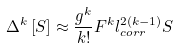Convert formula to latex. <formula><loc_0><loc_0><loc_500><loc_500>\Delta ^ { k } \left [ S \right ] \approx \frac { g ^ { k } } { k ! } F ^ { k } l _ { c o r r } ^ { 2 ( k - 1 ) } S</formula> 